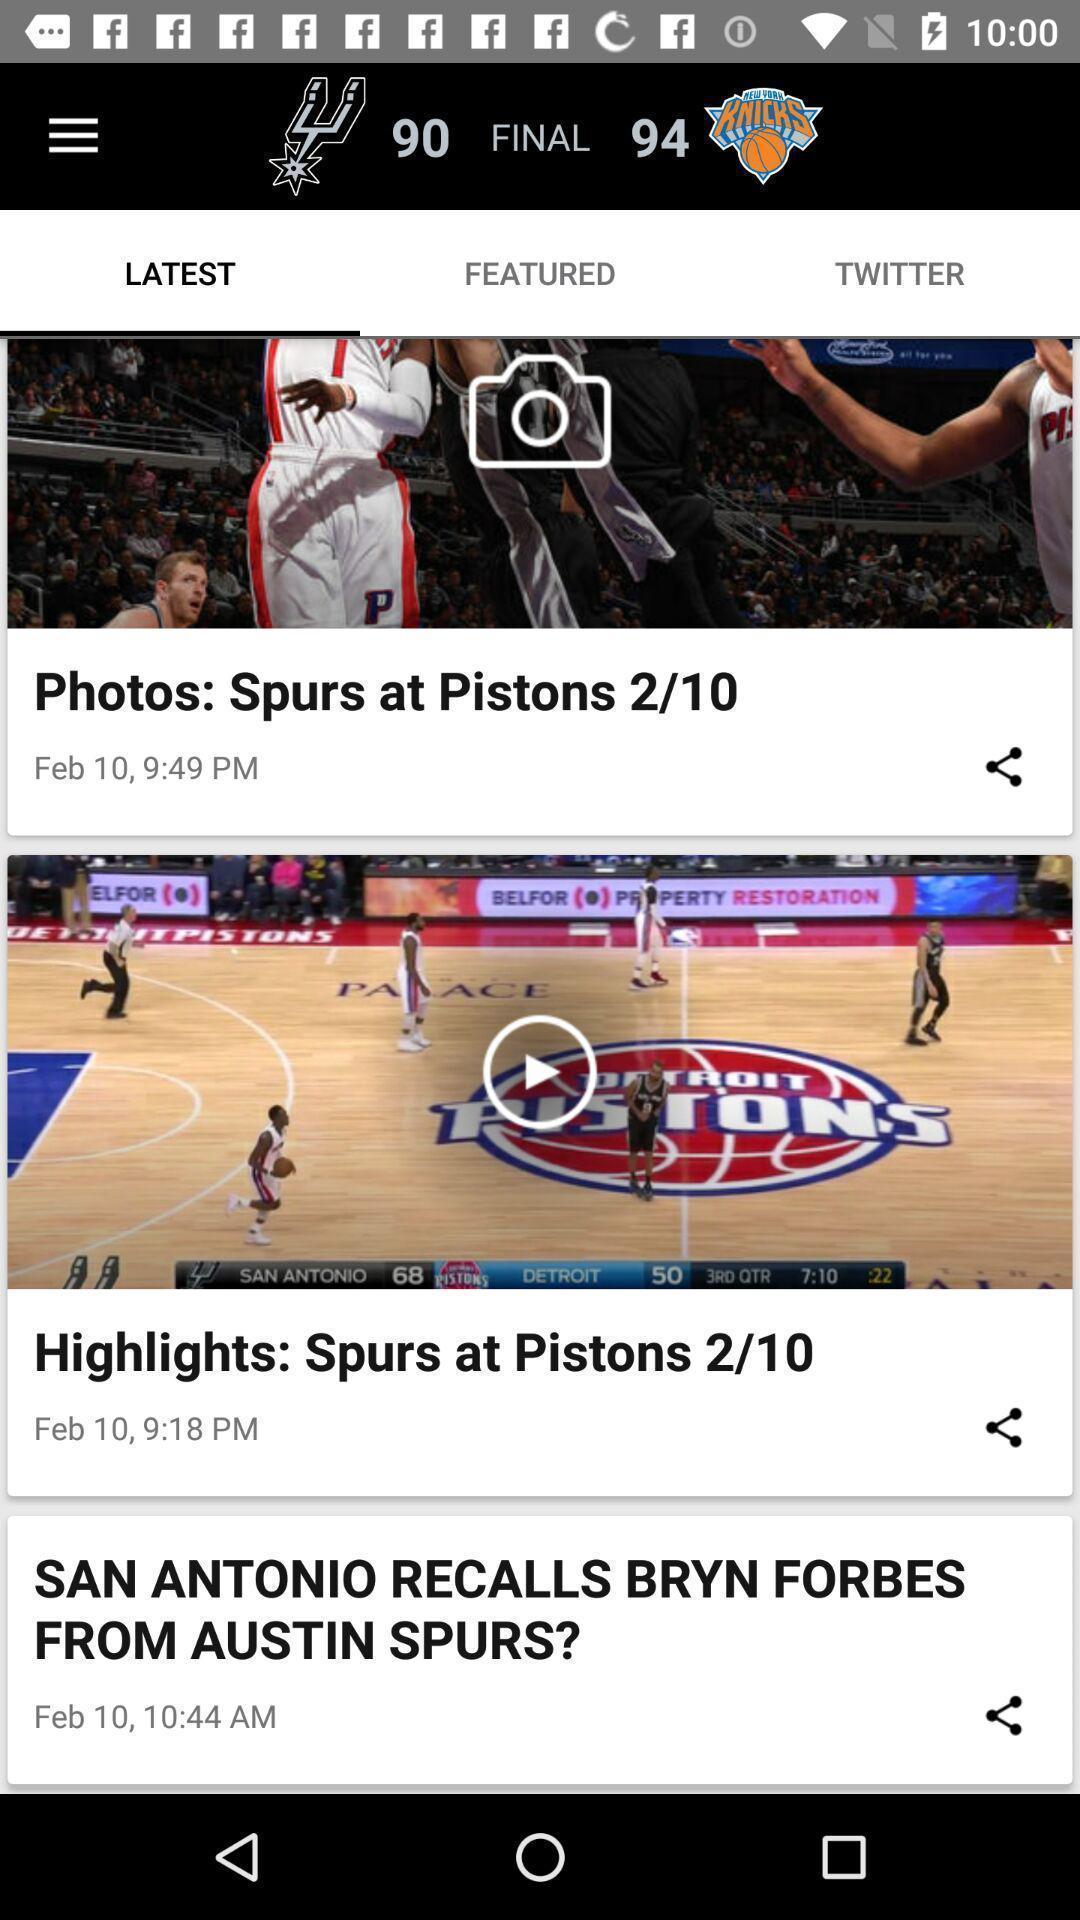Provide a detailed account of this screenshot. Screen page of a sports updates. 